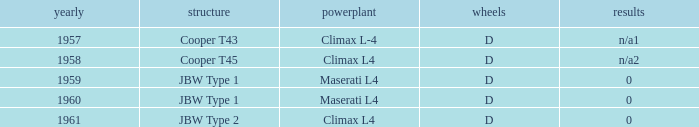What is the tyres for the JBW type 2 chassis? D. Give me the full table as a dictionary. {'header': ['yearly', 'structure', 'powerplant', 'wheels', 'results'], 'rows': [['1957', 'Cooper T43', 'Climax L-4', 'D', 'n/a1'], ['1958', 'Cooper T45', 'Climax L4', 'D', 'n/a2'], ['1959', 'JBW Type 1', 'Maserati L4', 'D', '0'], ['1960', 'JBW Type 1', 'Maserati L4', 'D', '0'], ['1961', 'JBW Type 2', 'Climax L4', 'D', '0']]} 